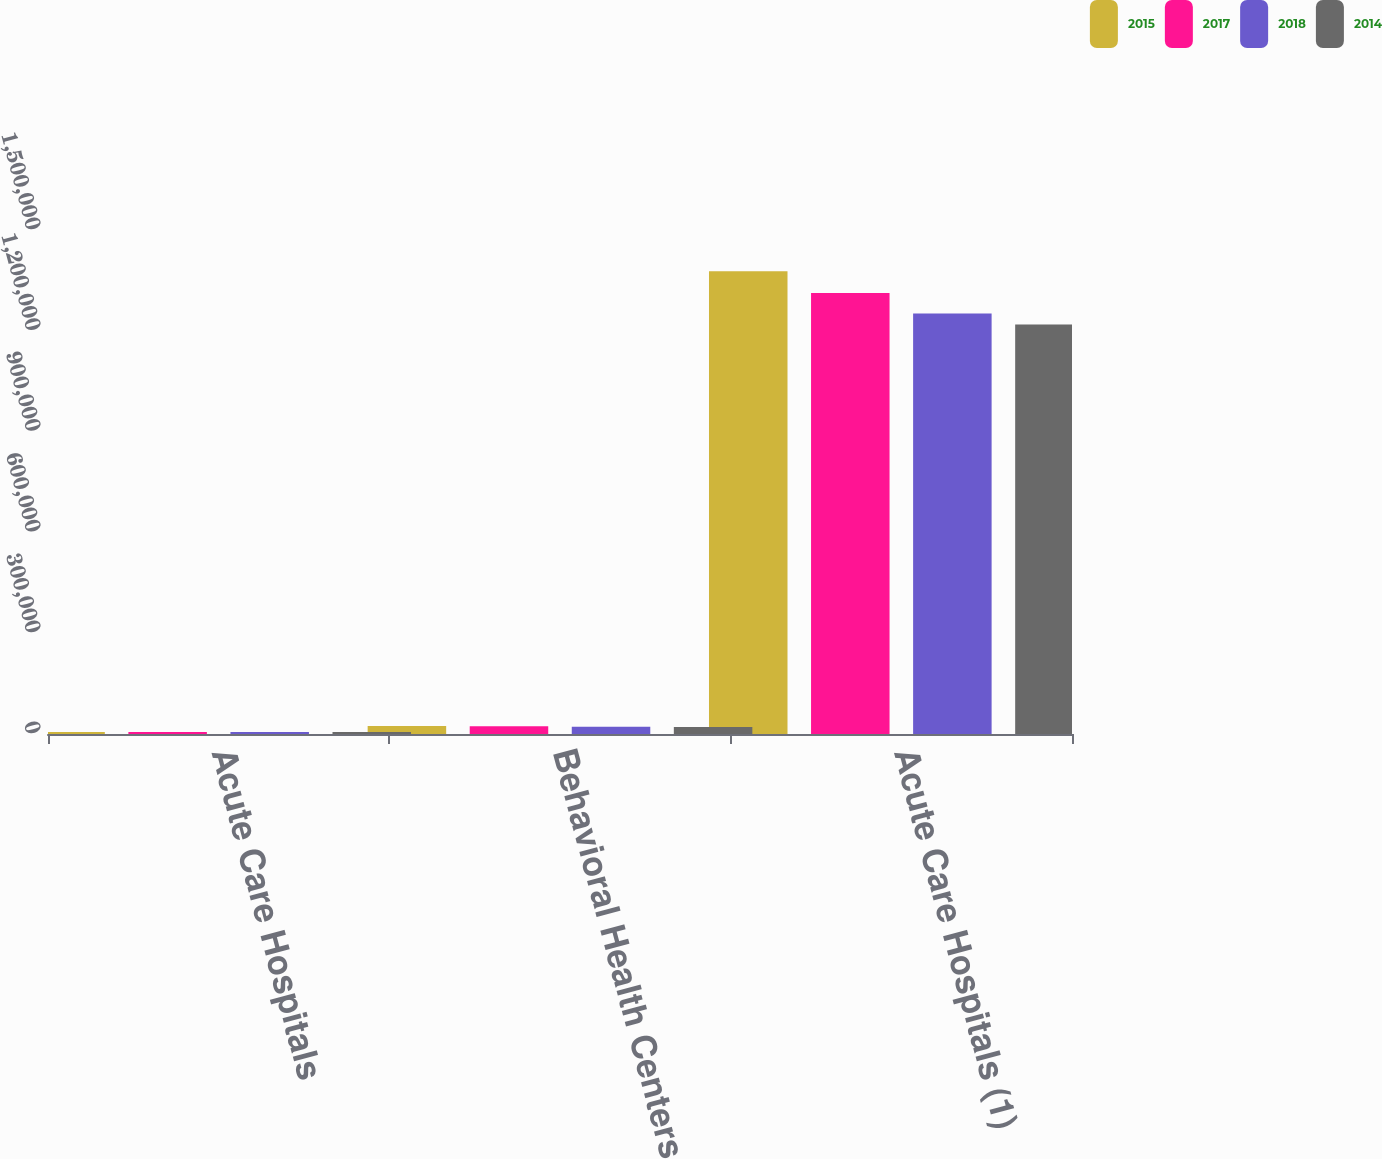Convert chart. <chart><loc_0><loc_0><loc_500><loc_500><stacked_bar_chart><ecel><fcel>Acute Care Hospitals<fcel>Behavioral Health Centers<fcel>Acute Care Hospitals (1)<nl><fcel>2015<fcel>6232<fcel>23509<fcel>1.37699e+06<nl><fcel>2017<fcel>6127<fcel>23151<fcel>1.31226e+06<nl><fcel>2018<fcel>5934<fcel>21829<fcel>1.25151e+06<nl><fcel>2014<fcel>5832<fcel>21202<fcel>1.21897e+06<nl></chart> 